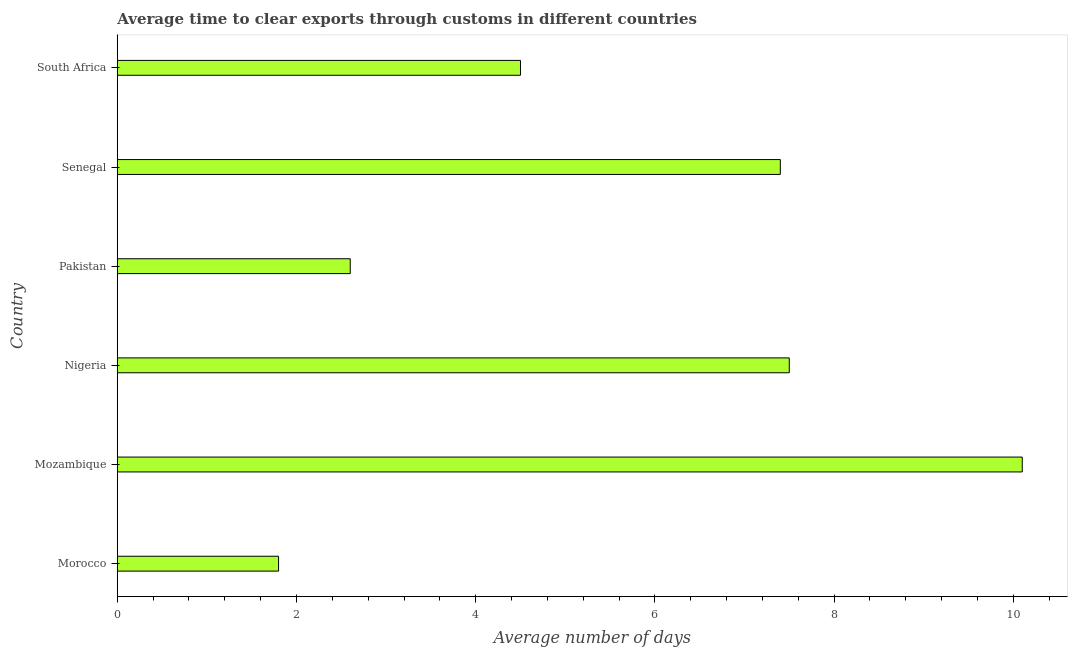Does the graph contain grids?
Give a very brief answer. No. What is the title of the graph?
Your response must be concise. Average time to clear exports through customs in different countries. What is the label or title of the X-axis?
Keep it short and to the point. Average number of days. Across all countries, what is the maximum time to clear exports through customs?
Provide a succinct answer. 10.1. In which country was the time to clear exports through customs maximum?
Make the answer very short. Mozambique. In which country was the time to clear exports through customs minimum?
Offer a terse response. Morocco. What is the sum of the time to clear exports through customs?
Your answer should be very brief. 33.9. What is the difference between the time to clear exports through customs in Nigeria and Pakistan?
Your answer should be compact. 4.9. What is the average time to clear exports through customs per country?
Provide a short and direct response. 5.65. What is the median time to clear exports through customs?
Make the answer very short. 5.95. In how many countries, is the time to clear exports through customs greater than 6.4 days?
Make the answer very short. 3. What is the ratio of the time to clear exports through customs in Morocco to that in Senegal?
Make the answer very short. 0.24. Is the time to clear exports through customs in Mozambique less than that in South Africa?
Your answer should be compact. No. Is the difference between the time to clear exports through customs in Pakistan and Senegal greater than the difference between any two countries?
Make the answer very short. No. What is the difference between the highest and the second highest time to clear exports through customs?
Make the answer very short. 2.6. How many bars are there?
Offer a very short reply. 6. How many countries are there in the graph?
Your response must be concise. 6. Are the values on the major ticks of X-axis written in scientific E-notation?
Your answer should be compact. No. What is the Average number of days of Nigeria?
Provide a succinct answer. 7.5. What is the Average number of days in Senegal?
Provide a succinct answer. 7.4. What is the difference between the Average number of days in Morocco and Mozambique?
Provide a short and direct response. -8.3. What is the difference between the Average number of days in Morocco and Nigeria?
Your response must be concise. -5.7. What is the difference between the Average number of days in Morocco and Senegal?
Offer a very short reply. -5.6. What is the difference between the Average number of days in Morocco and South Africa?
Your answer should be very brief. -2.7. What is the difference between the Average number of days in Mozambique and Nigeria?
Your answer should be very brief. 2.6. What is the difference between the Average number of days in Mozambique and South Africa?
Keep it short and to the point. 5.6. What is the difference between the Average number of days in Pakistan and South Africa?
Give a very brief answer. -1.9. What is the ratio of the Average number of days in Morocco to that in Mozambique?
Provide a short and direct response. 0.18. What is the ratio of the Average number of days in Morocco to that in Nigeria?
Offer a very short reply. 0.24. What is the ratio of the Average number of days in Morocco to that in Pakistan?
Ensure brevity in your answer.  0.69. What is the ratio of the Average number of days in Morocco to that in Senegal?
Make the answer very short. 0.24. What is the ratio of the Average number of days in Mozambique to that in Nigeria?
Provide a succinct answer. 1.35. What is the ratio of the Average number of days in Mozambique to that in Pakistan?
Give a very brief answer. 3.88. What is the ratio of the Average number of days in Mozambique to that in Senegal?
Keep it short and to the point. 1.36. What is the ratio of the Average number of days in Mozambique to that in South Africa?
Your response must be concise. 2.24. What is the ratio of the Average number of days in Nigeria to that in Pakistan?
Your answer should be compact. 2.88. What is the ratio of the Average number of days in Nigeria to that in South Africa?
Offer a terse response. 1.67. What is the ratio of the Average number of days in Pakistan to that in Senegal?
Your answer should be compact. 0.35. What is the ratio of the Average number of days in Pakistan to that in South Africa?
Offer a very short reply. 0.58. What is the ratio of the Average number of days in Senegal to that in South Africa?
Your response must be concise. 1.64. 